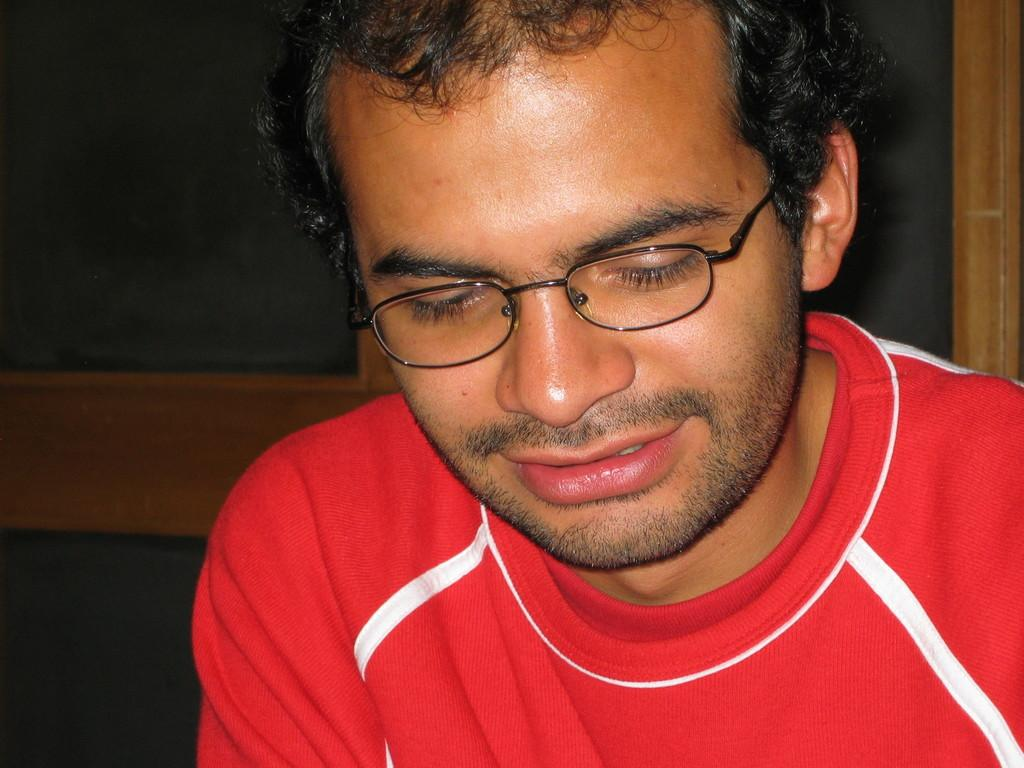What is the main subject of the image? There is a person in the image. What is the person wearing? The person is wearing a red T-shirt. Are there any accessories visible on the person? Yes, the person has spectacles. What can be seen behind the person in the image? There are other objects visible behind the person. What type of lumber is being used to construct the heart in the image? There is no lumber or heart present in the image; it features a person wearing a red T-shirt and spectacles. 